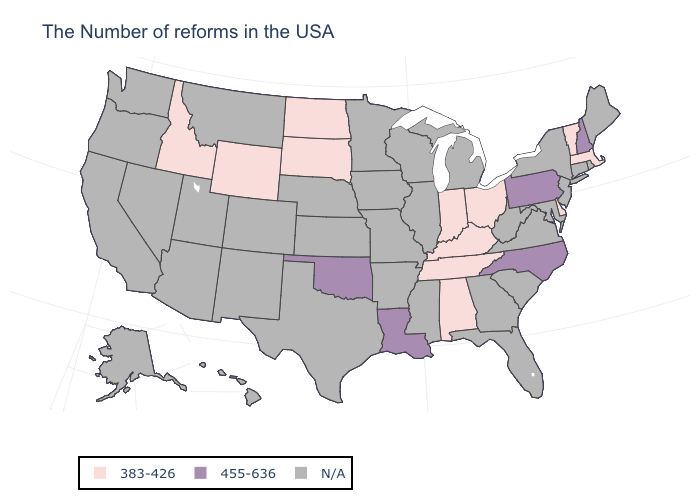Does Oklahoma have the highest value in the USA?
Give a very brief answer. Yes. What is the value of Rhode Island?
Answer briefly. N/A. Name the states that have a value in the range N/A?
Be succinct. Maine, Rhode Island, Connecticut, New York, New Jersey, Maryland, Virginia, South Carolina, West Virginia, Florida, Georgia, Michigan, Wisconsin, Illinois, Mississippi, Missouri, Arkansas, Minnesota, Iowa, Kansas, Nebraska, Texas, Colorado, New Mexico, Utah, Montana, Arizona, Nevada, California, Washington, Oregon, Alaska, Hawaii. Which states have the lowest value in the USA?
Write a very short answer. Massachusetts, Vermont, Delaware, Ohio, Kentucky, Indiana, Alabama, Tennessee, South Dakota, North Dakota, Wyoming, Idaho. Does the map have missing data?
Short answer required. Yes. Does the first symbol in the legend represent the smallest category?
Quick response, please. Yes. What is the value of Tennessee?
Keep it brief. 383-426. Name the states that have a value in the range N/A?
Keep it brief. Maine, Rhode Island, Connecticut, New York, New Jersey, Maryland, Virginia, South Carolina, West Virginia, Florida, Georgia, Michigan, Wisconsin, Illinois, Mississippi, Missouri, Arkansas, Minnesota, Iowa, Kansas, Nebraska, Texas, Colorado, New Mexico, Utah, Montana, Arizona, Nevada, California, Washington, Oregon, Alaska, Hawaii. Name the states that have a value in the range 455-636?
Give a very brief answer. New Hampshire, Pennsylvania, North Carolina, Louisiana, Oklahoma. Name the states that have a value in the range 455-636?
Give a very brief answer. New Hampshire, Pennsylvania, North Carolina, Louisiana, Oklahoma. What is the lowest value in the USA?
Be succinct. 383-426. Name the states that have a value in the range 383-426?
Keep it brief. Massachusetts, Vermont, Delaware, Ohio, Kentucky, Indiana, Alabama, Tennessee, South Dakota, North Dakota, Wyoming, Idaho. What is the value of Idaho?
Short answer required. 383-426. 